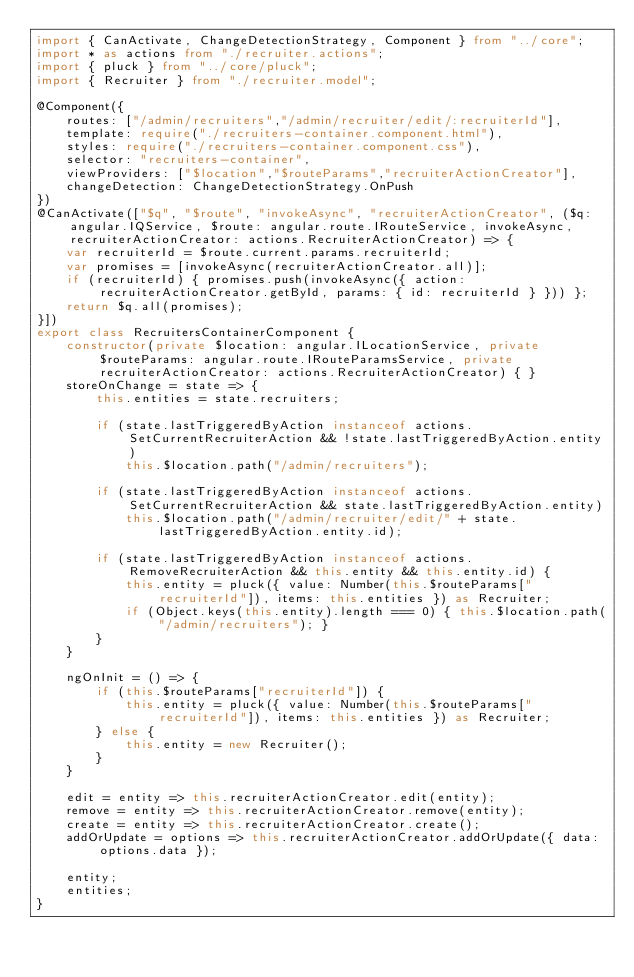Convert code to text. <code><loc_0><loc_0><loc_500><loc_500><_TypeScript_>import { CanActivate, ChangeDetectionStrategy, Component } from "../core";
import * as actions from "./recruiter.actions";
import { pluck } from "../core/pluck";
import { Recruiter } from "./recruiter.model";

@Component({
    routes: ["/admin/recruiters","/admin/recruiter/edit/:recruiterId"],
    template: require("./recruiters-container.component.html"),
    styles: require("./recruiters-container.component.css"),
    selector: "recruiters-container",
    viewProviders: ["$location","$routeParams","recruiterActionCreator"],
	changeDetection: ChangeDetectionStrategy.OnPush
})
@CanActivate(["$q", "$route", "invokeAsync", "recruiterActionCreator", ($q: angular.IQService, $route: angular.route.IRouteService, invokeAsync, recruiterActionCreator: actions.RecruiterActionCreator) => {
    var recruiterId = $route.current.params.recruiterId;
    var promises = [invokeAsync(recruiterActionCreator.all)];
    if (recruiterId) { promises.push(invokeAsync({ action: recruiterActionCreator.getById, params: { id: recruiterId } })) };
    return $q.all(promises);
}])
export class RecruitersContainerComponent { 
    constructor(private $location: angular.ILocationService, private $routeParams: angular.route.IRouteParamsService, private recruiterActionCreator: actions.RecruiterActionCreator) { }
    storeOnChange = state => {        
        this.entities = state.recruiters;

		if (state.lastTriggeredByAction instanceof actions.SetCurrentRecruiterAction && !state.lastTriggeredByAction.entity) 
            this.$location.path("/admin/recruiters");

        if (state.lastTriggeredByAction instanceof actions.SetCurrentRecruiterAction && state.lastTriggeredByAction.entity) 
            this.$location.path("/admin/recruiter/edit/" + state.lastTriggeredByAction.entity.id);
        
        if (state.lastTriggeredByAction instanceof actions.RemoveRecruiterAction && this.entity && this.entity.id) {
            this.entity = pluck({ value: Number(this.$routeParams["recruiterId"]), items: this.entities }) as Recruiter;
            if (Object.keys(this.entity).length === 0) { this.$location.path("/admin/recruiters"); }
        }
    }

    ngOnInit = () => {
        if (this.$routeParams["recruiterId"]) {
            this.entity = pluck({ value: Number(this.$routeParams["recruiterId"]), items: this.entities }) as Recruiter;
        } else {
            this.entity = new Recruiter();
        }
    }

    edit = entity => this.recruiterActionCreator.edit(entity);
    remove = entity => this.recruiterActionCreator.remove(entity);
    create = entity => this.recruiterActionCreator.create();
    addOrUpdate = options => this.recruiterActionCreator.addOrUpdate({ data: options.data });

    entity;
    entities;
}
</code> 